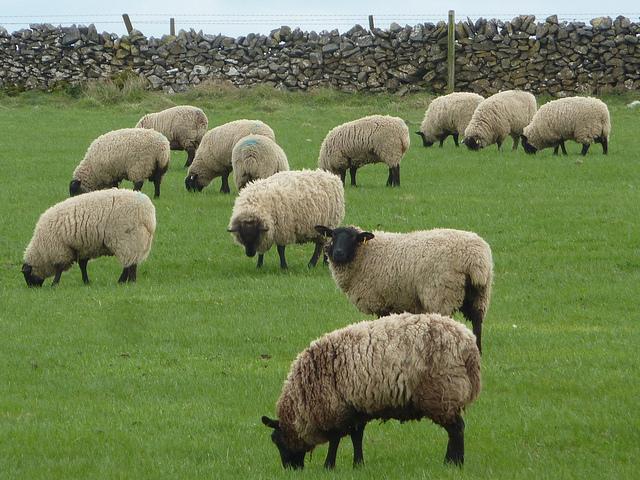How many sheep are looking up?
Give a very brief answer. 1. What is most of the sheep doing in the picture?
Be succinct. Grazing. What type of animal is this?
Keep it brief. Sheep. 